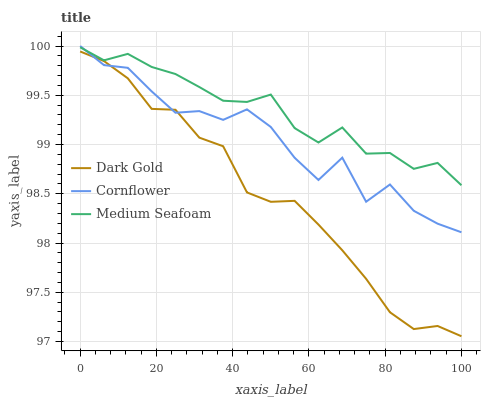Does Medium Seafoam have the minimum area under the curve?
Answer yes or no. No. Does Dark Gold have the maximum area under the curve?
Answer yes or no. No. Is Medium Seafoam the smoothest?
Answer yes or no. No. Is Medium Seafoam the roughest?
Answer yes or no. No. Does Medium Seafoam have the lowest value?
Answer yes or no. No. Does Medium Seafoam have the highest value?
Answer yes or no. No. Is Dark Gold less than Medium Seafoam?
Answer yes or no. Yes. Is Medium Seafoam greater than Dark Gold?
Answer yes or no. Yes. Does Dark Gold intersect Medium Seafoam?
Answer yes or no. No. 